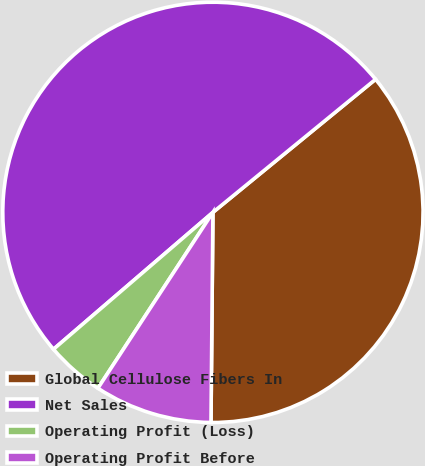Convert chart to OTSL. <chart><loc_0><loc_0><loc_500><loc_500><pie_chart><fcel>Global Cellulose Fibers In<fcel>Net Sales<fcel>Operating Profit (Loss)<fcel>Operating Profit Before<nl><fcel>36.06%<fcel>50.38%<fcel>4.49%<fcel>9.07%<nl></chart> 